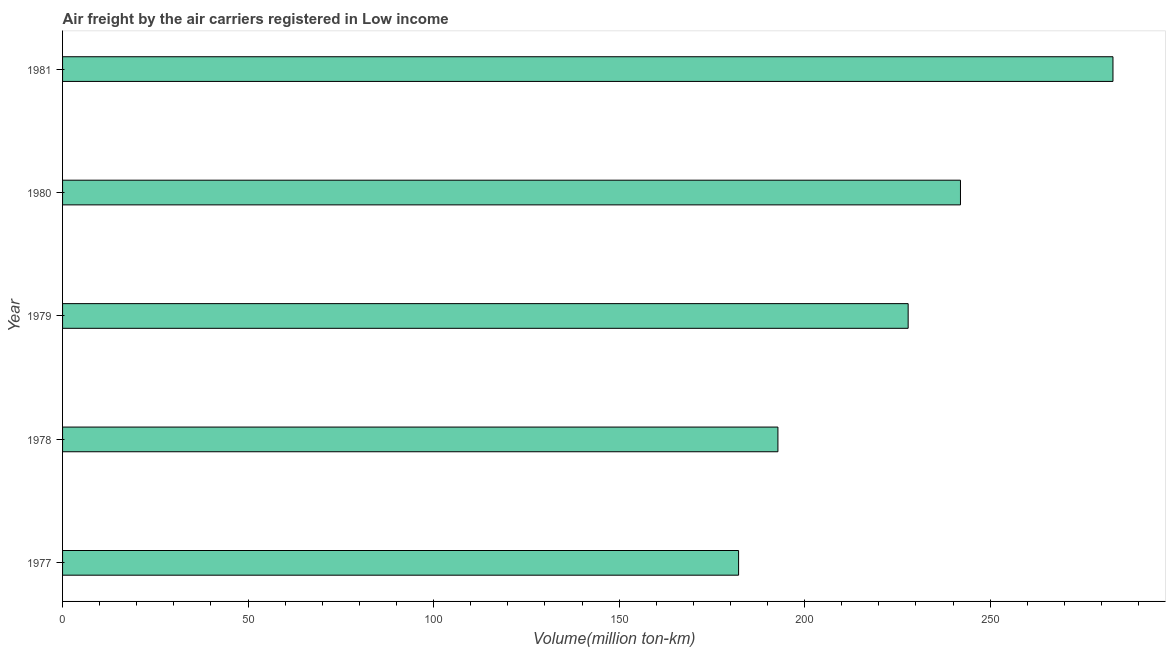Does the graph contain any zero values?
Give a very brief answer. No. Does the graph contain grids?
Provide a short and direct response. No. What is the title of the graph?
Make the answer very short. Air freight by the air carriers registered in Low income. What is the label or title of the X-axis?
Give a very brief answer. Volume(million ton-km). What is the label or title of the Y-axis?
Your response must be concise. Year. What is the air freight in 1981?
Your response must be concise. 283.1. Across all years, what is the maximum air freight?
Offer a very short reply. 283.1. Across all years, what is the minimum air freight?
Give a very brief answer. 182.2. What is the sum of the air freight?
Offer a very short reply. 1128. What is the difference between the air freight in 1979 and 1981?
Make the answer very short. -55.2. What is the average air freight per year?
Offer a terse response. 225.6. What is the median air freight?
Make the answer very short. 227.9. In how many years, is the air freight greater than 20 million ton-km?
Your answer should be compact. 5. What is the ratio of the air freight in 1978 to that in 1980?
Keep it short and to the point. 0.8. Is the difference between the air freight in 1977 and 1980 greater than the difference between any two years?
Provide a short and direct response. No. What is the difference between the highest and the second highest air freight?
Your answer should be compact. 41.1. Is the sum of the air freight in 1977 and 1978 greater than the maximum air freight across all years?
Your answer should be compact. Yes. What is the difference between the highest and the lowest air freight?
Give a very brief answer. 100.9. In how many years, is the air freight greater than the average air freight taken over all years?
Your answer should be very brief. 3. How many bars are there?
Provide a short and direct response. 5. Are all the bars in the graph horizontal?
Make the answer very short. Yes. How many years are there in the graph?
Make the answer very short. 5. What is the difference between two consecutive major ticks on the X-axis?
Your response must be concise. 50. Are the values on the major ticks of X-axis written in scientific E-notation?
Ensure brevity in your answer.  No. What is the Volume(million ton-km) in 1977?
Make the answer very short. 182.2. What is the Volume(million ton-km) of 1978?
Make the answer very short. 192.8. What is the Volume(million ton-km) in 1979?
Give a very brief answer. 227.9. What is the Volume(million ton-km) of 1980?
Offer a very short reply. 242. What is the Volume(million ton-km) in 1981?
Make the answer very short. 283.1. What is the difference between the Volume(million ton-km) in 1977 and 1979?
Your answer should be compact. -45.7. What is the difference between the Volume(million ton-km) in 1977 and 1980?
Offer a terse response. -59.8. What is the difference between the Volume(million ton-km) in 1977 and 1981?
Your response must be concise. -100.9. What is the difference between the Volume(million ton-km) in 1978 and 1979?
Your response must be concise. -35.1. What is the difference between the Volume(million ton-km) in 1978 and 1980?
Offer a very short reply. -49.2. What is the difference between the Volume(million ton-km) in 1978 and 1981?
Ensure brevity in your answer.  -90.3. What is the difference between the Volume(million ton-km) in 1979 and 1980?
Offer a very short reply. -14.1. What is the difference between the Volume(million ton-km) in 1979 and 1981?
Provide a succinct answer. -55.2. What is the difference between the Volume(million ton-km) in 1980 and 1981?
Give a very brief answer. -41.1. What is the ratio of the Volume(million ton-km) in 1977 to that in 1978?
Your response must be concise. 0.94. What is the ratio of the Volume(million ton-km) in 1977 to that in 1979?
Provide a succinct answer. 0.8. What is the ratio of the Volume(million ton-km) in 1977 to that in 1980?
Offer a terse response. 0.75. What is the ratio of the Volume(million ton-km) in 1977 to that in 1981?
Your response must be concise. 0.64. What is the ratio of the Volume(million ton-km) in 1978 to that in 1979?
Provide a succinct answer. 0.85. What is the ratio of the Volume(million ton-km) in 1978 to that in 1980?
Offer a terse response. 0.8. What is the ratio of the Volume(million ton-km) in 1978 to that in 1981?
Ensure brevity in your answer.  0.68. What is the ratio of the Volume(million ton-km) in 1979 to that in 1980?
Your answer should be compact. 0.94. What is the ratio of the Volume(million ton-km) in 1979 to that in 1981?
Offer a terse response. 0.81. What is the ratio of the Volume(million ton-km) in 1980 to that in 1981?
Offer a very short reply. 0.85. 